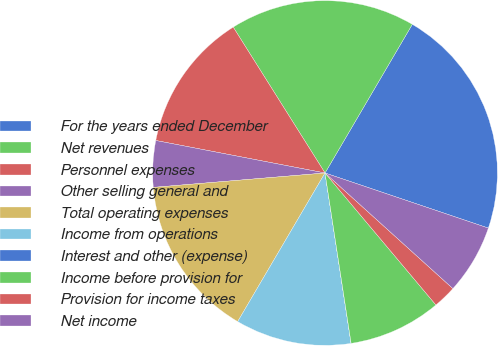Convert chart. <chart><loc_0><loc_0><loc_500><loc_500><pie_chart><fcel>For the years ended December<fcel>Net revenues<fcel>Personnel expenses<fcel>Other selling general and<fcel>Total operating expenses<fcel>Income from operations<fcel>Interest and other (expense)<fcel>Income before provision for<fcel>Provision for income taxes<fcel>Net income<nl><fcel>21.73%<fcel>17.39%<fcel>13.04%<fcel>4.35%<fcel>15.21%<fcel>10.87%<fcel>0.01%<fcel>8.7%<fcel>2.18%<fcel>6.52%<nl></chart> 